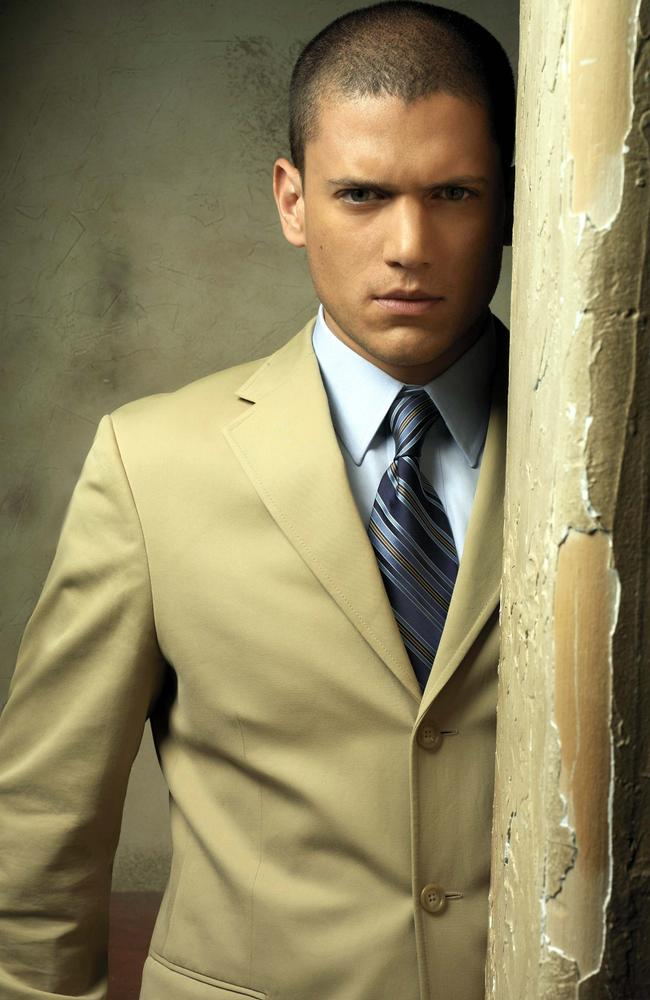Explain the visual content of the image in great detail. The image depicts an individual, dressed in a beige suit and a blue striped tie, positioned against a backdrop of a textured wall with visible signs of peeling paint, adding a rustic and somewhat weathered aesthetic to the overall scene. The person's serious expression and direct gaze into the camera lens suggest a sense of determination or contemplation. The lighting is soft, highlighting the textures on the wall and the details of the suit, creating a visually engaging composition. The contrast between the sophisticated attire and the dilapidated background adds a layer of depth and intrigue to the image, inviting viewers to ponder the story or themes behind the photograph. 